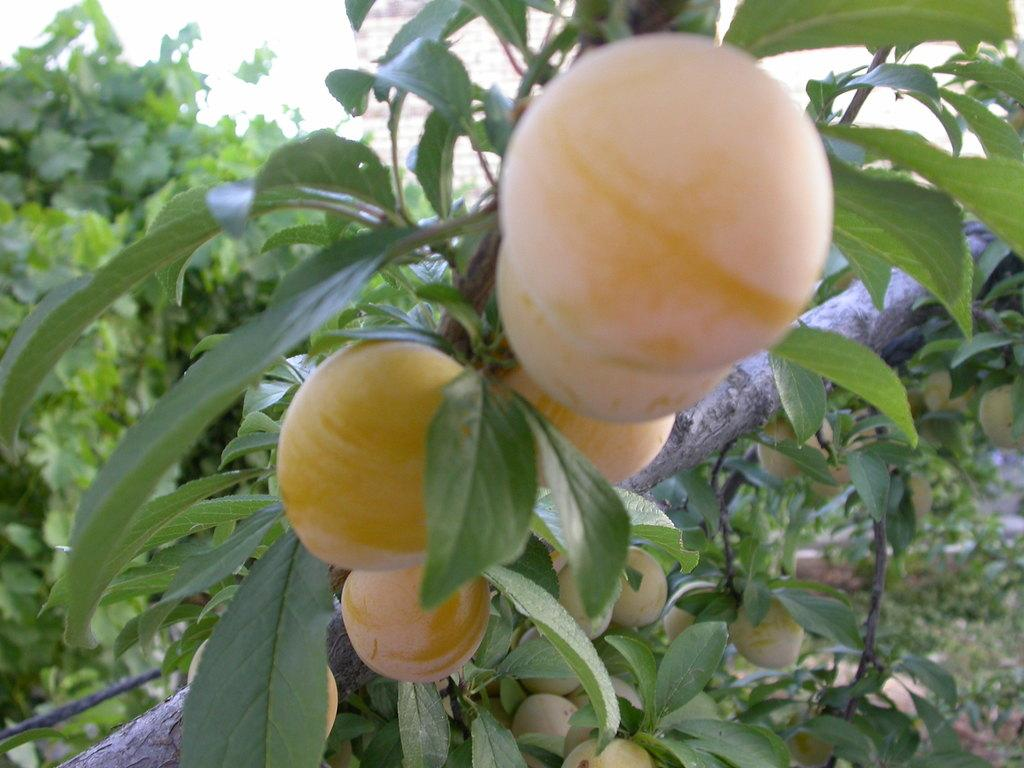What type of food is present in the image? There are fruits in the image. What is the color of the fruits? The fruits are in cream color. What other elements can be seen in the image besides the fruits? There are green color leaves in the image. What is visible in the background of the image? The sky is visible in the image. What is the color of the sky in the image? The sky appears to be white in color. What type of noise can be heard coming from the frog in the image? There is no frog present in the image, so it is not possible to determine what noise, if any, might be heard. 